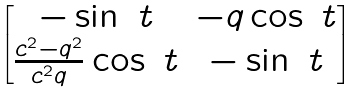<formula> <loc_0><loc_0><loc_500><loc_500>\begin{bmatrix} - \sin \ t & - q \cos \ t \\ \frac { c ^ { 2 } - q ^ { 2 } } { c ^ { 2 } q } \cos \ t & - \sin \ t \end{bmatrix}</formula> 